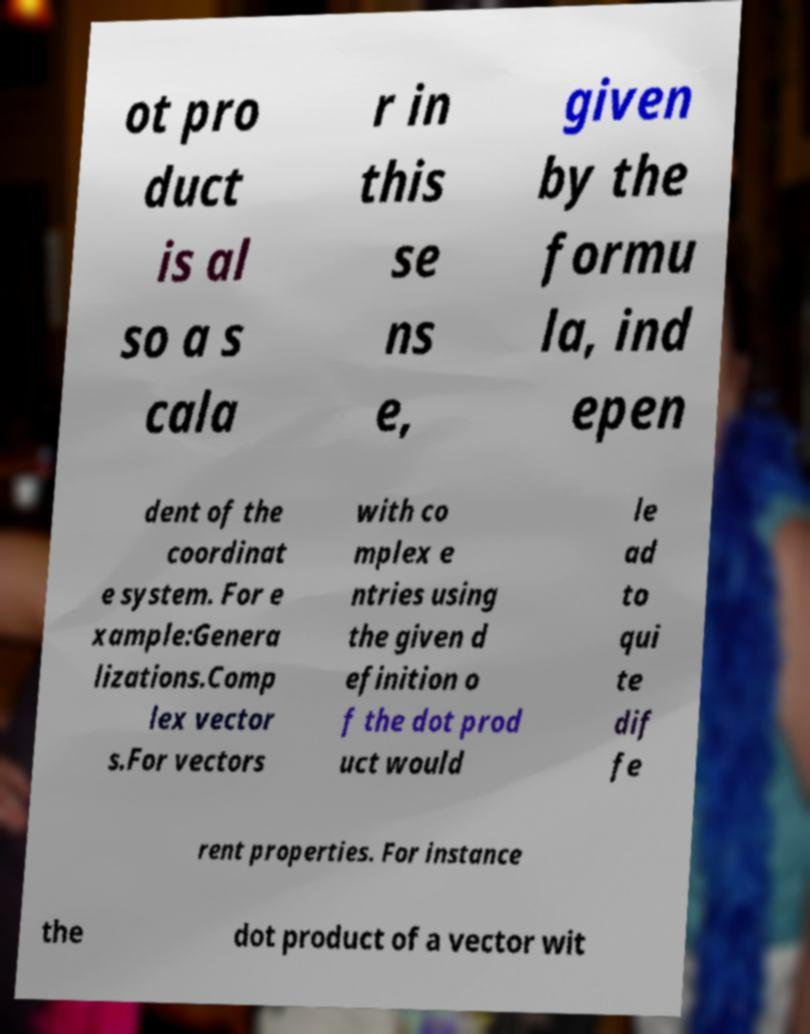What messages or text are displayed in this image? I need them in a readable, typed format. ot pro duct is al so a s cala r in this se ns e, given by the formu la, ind epen dent of the coordinat e system. For e xample:Genera lizations.Comp lex vector s.For vectors with co mplex e ntries using the given d efinition o f the dot prod uct would le ad to qui te dif fe rent properties. For instance the dot product of a vector wit 